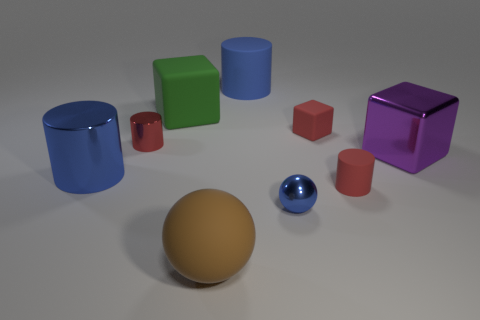Is the shape of the red metallic thing the same as the blue rubber thing?
Keep it short and to the point. Yes. There is a rubber cube that is left of the blue sphere; is its size the same as the ball behind the brown rubber sphere?
Give a very brief answer. No. There is a matte object that is to the right of the large blue rubber thing and behind the big metallic cylinder; what size is it?
Provide a succinct answer. Small. The other large object that is the same shape as the big purple object is what color?
Offer a terse response. Green. Are there any cylinders in front of the tiny matte thing that is behind the small red metal thing?
Provide a succinct answer. Yes. How many tiny red matte cylinders are there?
Give a very brief answer. 1. Is the color of the tiny metallic sphere the same as the large cylinder right of the large brown rubber object?
Offer a terse response. Yes. Are there more shiny balls than small green matte balls?
Offer a terse response. Yes. Is there anything else that is the same color as the large metallic cylinder?
Offer a very short reply. Yes. What number of other things are the same size as the brown matte sphere?
Give a very brief answer. 4. 